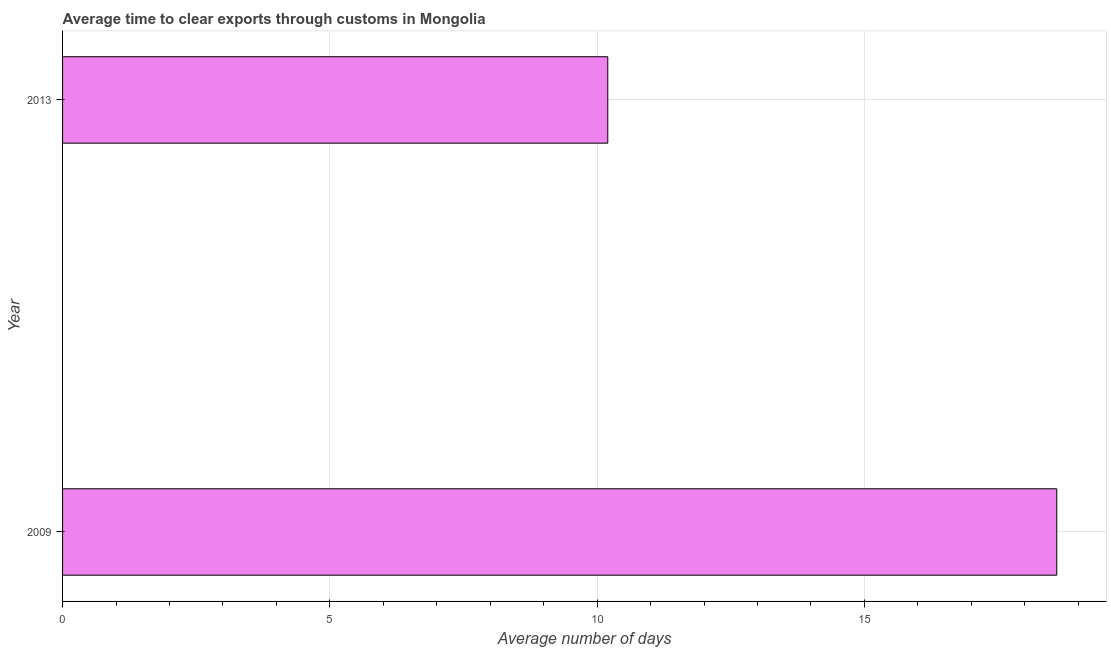What is the title of the graph?
Keep it short and to the point. Average time to clear exports through customs in Mongolia. What is the label or title of the X-axis?
Give a very brief answer. Average number of days. What is the label or title of the Y-axis?
Ensure brevity in your answer.  Year. Across all years, what is the maximum time to clear exports through customs?
Offer a terse response. 18.6. Across all years, what is the minimum time to clear exports through customs?
Ensure brevity in your answer.  10.2. What is the sum of the time to clear exports through customs?
Make the answer very short. 28.8. What is the difference between the time to clear exports through customs in 2009 and 2013?
Your answer should be compact. 8.4. What is the average time to clear exports through customs per year?
Provide a short and direct response. 14.4. What is the median time to clear exports through customs?
Ensure brevity in your answer.  14.4. In how many years, is the time to clear exports through customs greater than 17 days?
Give a very brief answer. 1. What is the ratio of the time to clear exports through customs in 2009 to that in 2013?
Offer a terse response. 1.82. Are all the bars in the graph horizontal?
Your answer should be very brief. Yes. What is the difference between two consecutive major ticks on the X-axis?
Your response must be concise. 5. What is the Average number of days in 2013?
Your answer should be very brief. 10.2. What is the difference between the Average number of days in 2009 and 2013?
Give a very brief answer. 8.4. What is the ratio of the Average number of days in 2009 to that in 2013?
Make the answer very short. 1.82. 